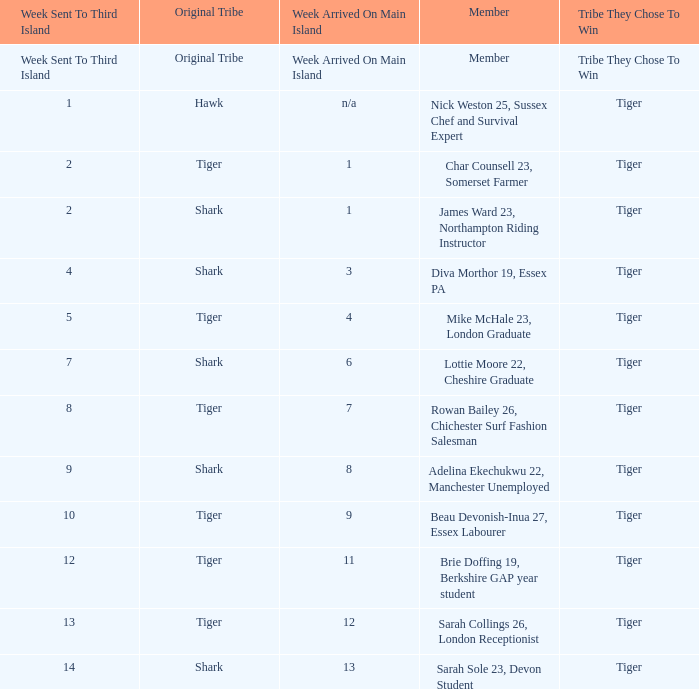What week was the member who arrived on the main island in week 6 sent to the third island? 7.0. 